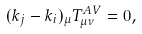Convert formula to latex. <formula><loc_0><loc_0><loc_500><loc_500>( k _ { j } - k _ { i } ) _ { \mu } T _ { \mu \nu } ^ { A V } = 0 ,</formula> 